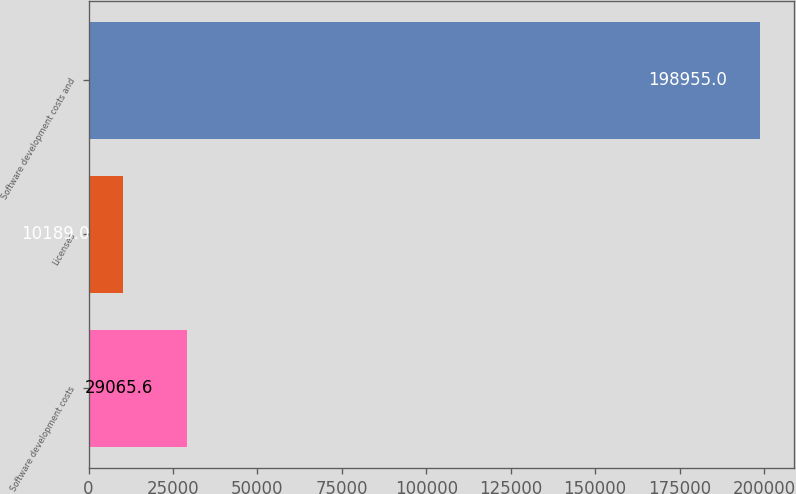Convert chart to OTSL. <chart><loc_0><loc_0><loc_500><loc_500><bar_chart><fcel>Software development costs<fcel>Licenses<fcel>Software development costs and<nl><fcel>29065.6<fcel>10189<fcel>198955<nl></chart> 